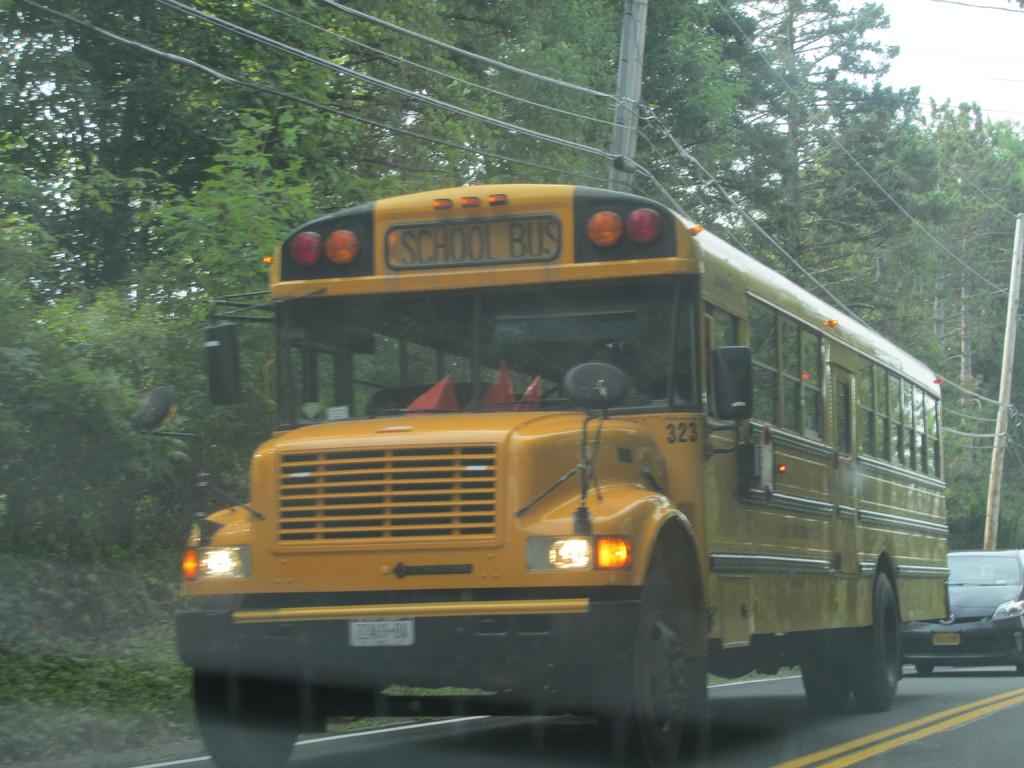<image>
Write a terse but informative summary of the picture. School bus 323 drives on the road with its headlights on. 